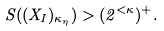Convert formula to latex. <formula><loc_0><loc_0><loc_500><loc_500>S ( ( X _ { I } ) _ { \kappa _ { \eta } } ) > ( 2 ^ { < \kappa } ) ^ { + } .</formula> 